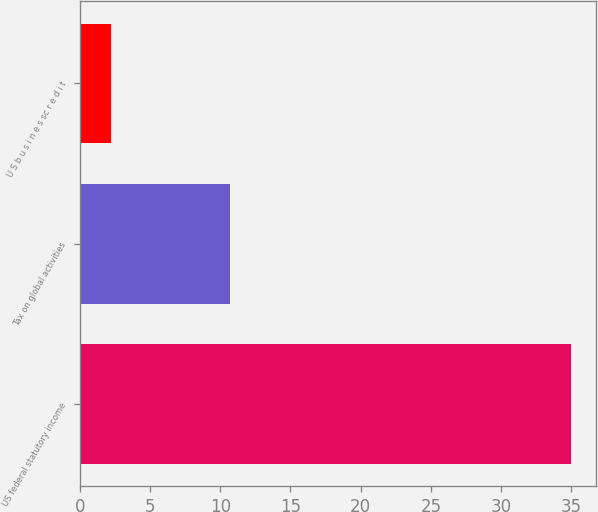Convert chart to OTSL. <chart><loc_0><loc_0><loc_500><loc_500><bar_chart><fcel>US federal statutory income<fcel>Tax on global activities<fcel>U S b u s i n e s sc r e d i t<nl><fcel>35<fcel>10.7<fcel>2.2<nl></chart> 